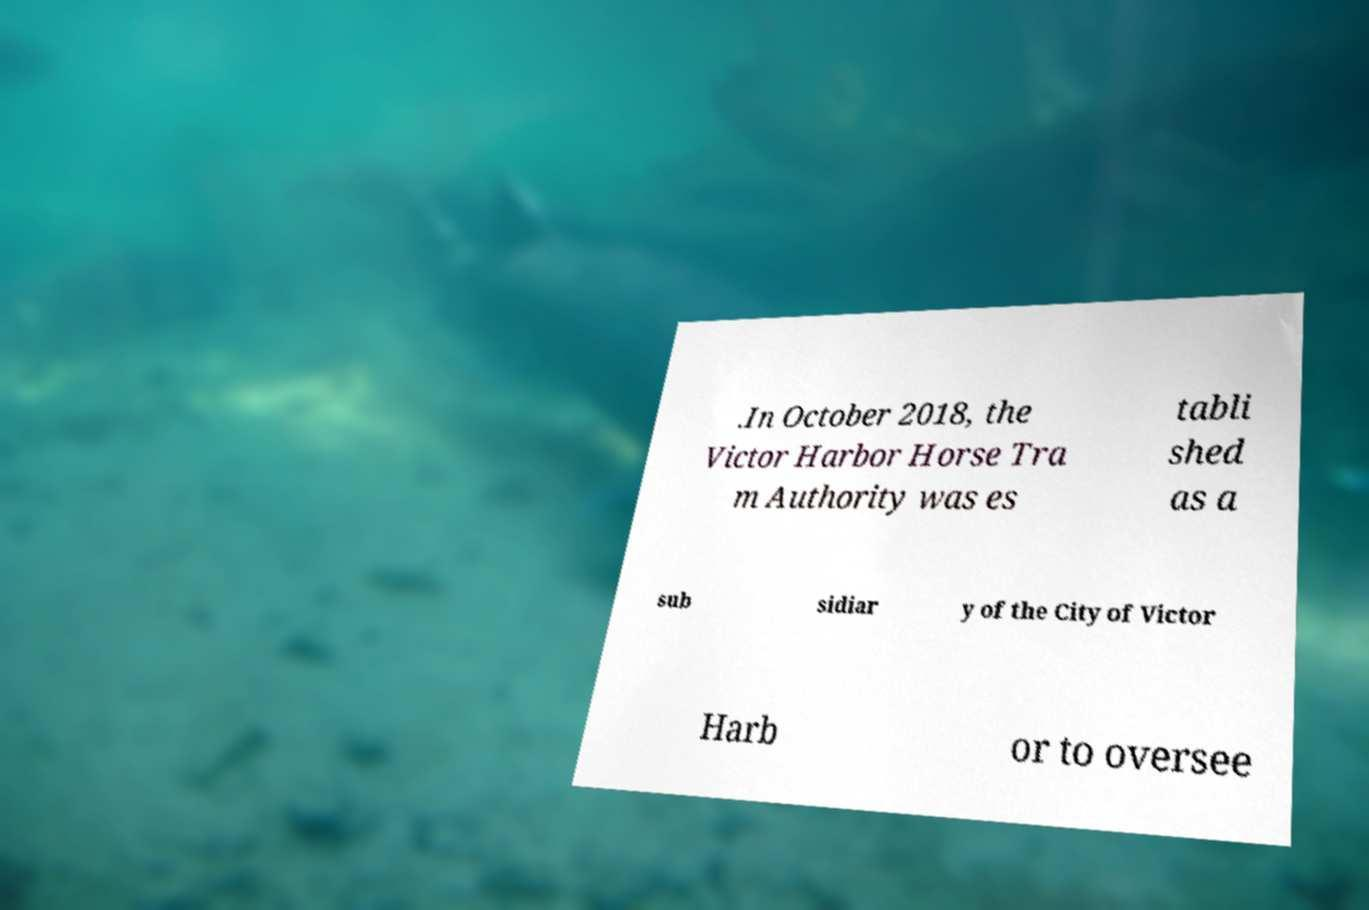Please read and relay the text visible in this image. What does it say? .In October 2018, the Victor Harbor Horse Tra m Authority was es tabli shed as a sub sidiar y of the City of Victor Harb or to oversee 